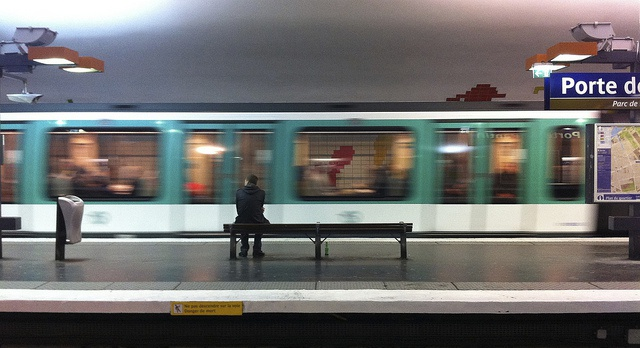Describe the objects in this image and their specific colors. I can see train in white, gray, lightgray, black, and teal tones, bench in white, black, lightgray, gray, and darkgray tones, and people in white, black, and gray tones in this image. 